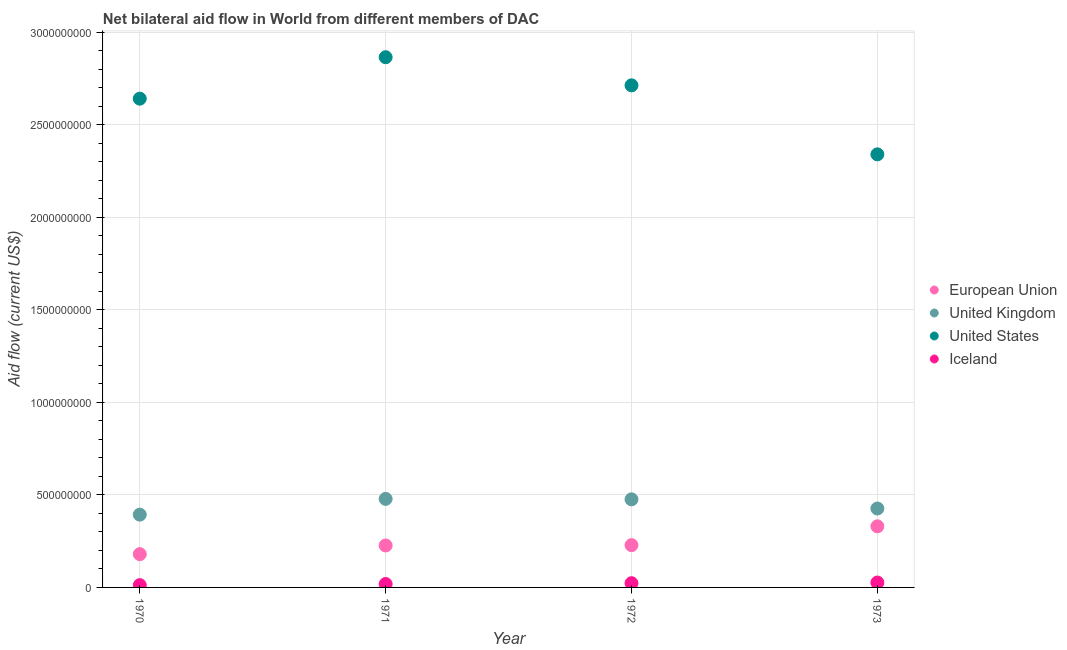How many different coloured dotlines are there?
Offer a very short reply. 4. What is the amount of aid given by us in 1972?
Your answer should be compact. 2.71e+09. Across all years, what is the maximum amount of aid given by eu?
Keep it short and to the point. 3.30e+08. Across all years, what is the minimum amount of aid given by uk?
Offer a very short reply. 3.94e+08. In which year was the amount of aid given by uk maximum?
Offer a terse response. 1971. What is the total amount of aid given by uk in the graph?
Provide a succinct answer. 1.77e+09. What is the difference between the amount of aid given by eu in 1970 and that in 1971?
Offer a terse response. -4.69e+07. What is the difference between the amount of aid given by us in 1972 and the amount of aid given by iceland in 1970?
Provide a succinct answer. 2.70e+09. What is the average amount of aid given by eu per year?
Make the answer very short. 2.41e+08. In the year 1972, what is the difference between the amount of aid given by us and amount of aid given by iceland?
Your answer should be compact. 2.69e+09. In how many years, is the amount of aid given by iceland greater than 1700000000 US$?
Provide a succinct answer. 0. What is the ratio of the amount of aid given by eu in 1971 to that in 1972?
Provide a short and direct response. 0.99. Is the amount of aid given by eu in 1970 less than that in 1973?
Give a very brief answer. Yes. What is the difference between the highest and the second highest amount of aid given by iceland?
Offer a terse response. 3.48e+06. What is the difference between the highest and the lowest amount of aid given by us?
Make the answer very short. 5.25e+08. In how many years, is the amount of aid given by iceland greater than the average amount of aid given by iceland taken over all years?
Provide a succinct answer. 2. Is it the case that in every year, the sum of the amount of aid given by iceland and amount of aid given by us is greater than the sum of amount of aid given by eu and amount of aid given by uk?
Provide a succinct answer. No. Is it the case that in every year, the sum of the amount of aid given by eu and amount of aid given by uk is greater than the amount of aid given by us?
Keep it short and to the point. No. Does the amount of aid given by iceland monotonically increase over the years?
Make the answer very short. Yes. Is the amount of aid given by iceland strictly less than the amount of aid given by uk over the years?
Offer a terse response. Yes. What is the difference between two consecutive major ticks on the Y-axis?
Ensure brevity in your answer.  5.00e+08. Does the graph contain grids?
Your response must be concise. Yes. What is the title of the graph?
Provide a short and direct response. Net bilateral aid flow in World from different members of DAC. Does "Third 20% of population" appear as one of the legend labels in the graph?
Your answer should be compact. No. What is the label or title of the Y-axis?
Make the answer very short. Aid flow (current US$). What is the Aid flow (current US$) in European Union in 1970?
Provide a succinct answer. 1.80e+08. What is the Aid flow (current US$) in United Kingdom in 1970?
Your response must be concise. 3.94e+08. What is the Aid flow (current US$) in United States in 1970?
Provide a short and direct response. 2.64e+09. What is the Aid flow (current US$) in Iceland in 1970?
Offer a terse response. 1.24e+07. What is the Aid flow (current US$) of European Union in 1971?
Ensure brevity in your answer.  2.27e+08. What is the Aid flow (current US$) of United Kingdom in 1971?
Keep it short and to the point. 4.79e+08. What is the Aid flow (current US$) in United States in 1971?
Your answer should be very brief. 2.87e+09. What is the Aid flow (current US$) of Iceland in 1971?
Ensure brevity in your answer.  1.85e+07. What is the Aid flow (current US$) of European Union in 1972?
Make the answer very short. 2.29e+08. What is the Aid flow (current US$) of United Kingdom in 1972?
Make the answer very short. 4.76e+08. What is the Aid flow (current US$) of United States in 1972?
Provide a short and direct response. 2.71e+09. What is the Aid flow (current US$) of Iceland in 1972?
Ensure brevity in your answer.  2.30e+07. What is the Aid flow (current US$) in European Union in 1973?
Ensure brevity in your answer.  3.30e+08. What is the Aid flow (current US$) of United Kingdom in 1973?
Your answer should be very brief. 4.26e+08. What is the Aid flow (current US$) of United States in 1973?
Offer a terse response. 2.34e+09. What is the Aid flow (current US$) of Iceland in 1973?
Your answer should be compact. 2.65e+07. Across all years, what is the maximum Aid flow (current US$) in European Union?
Give a very brief answer. 3.30e+08. Across all years, what is the maximum Aid flow (current US$) in United Kingdom?
Your response must be concise. 4.79e+08. Across all years, what is the maximum Aid flow (current US$) in United States?
Offer a very short reply. 2.87e+09. Across all years, what is the maximum Aid flow (current US$) in Iceland?
Your response must be concise. 2.65e+07. Across all years, what is the minimum Aid flow (current US$) in European Union?
Make the answer very short. 1.80e+08. Across all years, what is the minimum Aid flow (current US$) in United Kingdom?
Your response must be concise. 3.94e+08. Across all years, what is the minimum Aid flow (current US$) of United States?
Keep it short and to the point. 2.34e+09. Across all years, what is the minimum Aid flow (current US$) of Iceland?
Ensure brevity in your answer.  1.24e+07. What is the total Aid flow (current US$) in European Union in the graph?
Offer a very short reply. 9.65e+08. What is the total Aid flow (current US$) in United Kingdom in the graph?
Offer a terse response. 1.77e+09. What is the total Aid flow (current US$) of United States in the graph?
Give a very brief answer. 1.06e+1. What is the total Aid flow (current US$) in Iceland in the graph?
Give a very brief answer. 8.04e+07. What is the difference between the Aid flow (current US$) in European Union in 1970 and that in 1971?
Ensure brevity in your answer.  -4.69e+07. What is the difference between the Aid flow (current US$) in United Kingdom in 1970 and that in 1971?
Your answer should be very brief. -8.51e+07. What is the difference between the Aid flow (current US$) in United States in 1970 and that in 1971?
Ensure brevity in your answer.  -2.24e+08. What is the difference between the Aid flow (current US$) of Iceland in 1970 and that in 1971?
Ensure brevity in your answer.  -6.11e+06. What is the difference between the Aid flow (current US$) of European Union in 1970 and that in 1972?
Ensure brevity in your answer.  -4.86e+07. What is the difference between the Aid flow (current US$) of United Kingdom in 1970 and that in 1972?
Offer a very short reply. -8.26e+07. What is the difference between the Aid flow (current US$) of United States in 1970 and that in 1972?
Your answer should be very brief. -7.20e+07. What is the difference between the Aid flow (current US$) in Iceland in 1970 and that in 1972?
Provide a succinct answer. -1.06e+07. What is the difference between the Aid flow (current US$) of European Union in 1970 and that in 1973?
Make the answer very short. -1.50e+08. What is the difference between the Aid flow (current US$) in United Kingdom in 1970 and that in 1973?
Keep it short and to the point. -3.30e+07. What is the difference between the Aid flow (current US$) in United States in 1970 and that in 1973?
Provide a succinct answer. 3.01e+08. What is the difference between the Aid flow (current US$) in Iceland in 1970 and that in 1973?
Your answer should be compact. -1.41e+07. What is the difference between the Aid flow (current US$) of European Union in 1971 and that in 1972?
Make the answer very short. -1.74e+06. What is the difference between the Aid flow (current US$) in United Kingdom in 1971 and that in 1972?
Provide a succinct answer. 2.50e+06. What is the difference between the Aid flow (current US$) in United States in 1971 and that in 1972?
Provide a succinct answer. 1.52e+08. What is the difference between the Aid flow (current US$) in Iceland in 1971 and that in 1972?
Your response must be concise. -4.51e+06. What is the difference between the Aid flow (current US$) in European Union in 1971 and that in 1973?
Offer a very short reply. -1.04e+08. What is the difference between the Aid flow (current US$) in United Kingdom in 1971 and that in 1973?
Give a very brief answer. 5.22e+07. What is the difference between the Aid flow (current US$) of United States in 1971 and that in 1973?
Give a very brief answer. 5.25e+08. What is the difference between the Aid flow (current US$) in Iceland in 1971 and that in 1973?
Provide a succinct answer. -7.99e+06. What is the difference between the Aid flow (current US$) in European Union in 1972 and that in 1973?
Offer a very short reply. -1.02e+08. What is the difference between the Aid flow (current US$) in United Kingdom in 1972 and that in 1973?
Offer a terse response. 4.97e+07. What is the difference between the Aid flow (current US$) in United States in 1972 and that in 1973?
Ensure brevity in your answer.  3.73e+08. What is the difference between the Aid flow (current US$) in Iceland in 1972 and that in 1973?
Your response must be concise. -3.48e+06. What is the difference between the Aid flow (current US$) of European Union in 1970 and the Aid flow (current US$) of United Kingdom in 1971?
Your answer should be very brief. -2.99e+08. What is the difference between the Aid flow (current US$) of European Union in 1970 and the Aid flow (current US$) of United States in 1971?
Your answer should be compact. -2.69e+09. What is the difference between the Aid flow (current US$) of European Union in 1970 and the Aid flow (current US$) of Iceland in 1971?
Give a very brief answer. 1.61e+08. What is the difference between the Aid flow (current US$) of United Kingdom in 1970 and the Aid flow (current US$) of United States in 1971?
Make the answer very short. -2.47e+09. What is the difference between the Aid flow (current US$) of United Kingdom in 1970 and the Aid flow (current US$) of Iceland in 1971?
Your response must be concise. 3.75e+08. What is the difference between the Aid flow (current US$) of United States in 1970 and the Aid flow (current US$) of Iceland in 1971?
Provide a succinct answer. 2.62e+09. What is the difference between the Aid flow (current US$) in European Union in 1970 and the Aid flow (current US$) in United Kingdom in 1972?
Keep it short and to the point. -2.96e+08. What is the difference between the Aid flow (current US$) of European Union in 1970 and the Aid flow (current US$) of United States in 1972?
Offer a very short reply. -2.53e+09. What is the difference between the Aid flow (current US$) in European Union in 1970 and the Aid flow (current US$) in Iceland in 1972?
Give a very brief answer. 1.57e+08. What is the difference between the Aid flow (current US$) in United Kingdom in 1970 and the Aid flow (current US$) in United States in 1972?
Your response must be concise. -2.32e+09. What is the difference between the Aid flow (current US$) of United Kingdom in 1970 and the Aid flow (current US$) of Iceland in 1972?
Your answer should be very brief. 3.70e+08. What is the difference between the Aid flow (current US$) of United States in 1970 and the Aid flow (current US$) of Iceland in 1972?
Offer a very short reply. 2.62e+09. What is the difference between the Aid flow (current US$) in European Union in 1970 and the Aid flow (current US$) in United Kingdom in 1973?
Provide a short and direct response. -2.47e+08. What is the difference between the Aid flow (current US$) of European Union in 1970 and the Aid flow (current US$) of United States in 1973?
Keep it short and to the point. -2.16e+09. What is the difference between the Aid flow (current US$) of European Union in 1970 and the Aid flow (current US$) of Iceland in 1973?
Your response must be concise. 1.53e+08. What is the difference between the Aid flow (current US$) in United Kingdom in 1970 and the Aid flow (current US$) in United States in 1973?
Keep it short and to the point. -1.95e+09. What is the difference between the Aid flow (current US$) in United Kingdom in 1970 and the Aid flow (current US$) in Iceland in 1973?
Give a very brief answer. 3.67e+08. What is the difference between the Aid flow (current US$) of United States in 1970 and the Aid flow (current US$) of Iceland in 1973?
Your answer should be very brief. 2.62e+09. What is the difference between the Aid flow (current US$) in European Union in 1971 and the Aid flow (current US$) in United Kingdom in 1972?
Your response must be concise. -2.49e+08. What is the difference between the Aid flow (current US$) in European Union in 1971 and the Aid flow (current US$) in United States in 1972?
Offer a very short reply. -2.49e+09. What is the difference between the Aid flow (current US$) in European Union in 1971 and the Aid flow (current US$) in Iceland in 1972?
Ensure brevity in your answer.  2.04e+08. What is the difference between the Aid flow (current US$) of United Kingdom in 1971 and the Aid flow (current US$) of United States in 1972?
Your answer should be compact. -2.24e+09. What is the difference between the Aid flow (current US$) in United Kingdom in 1971 and the Aid flow (current US$) in Iceland in 1972?
Provide a succinct answer. 4.56e+08. What is the difference between the Aid flow (current US$) of United States in 1971 and the Aid flow (current US$) of Iceland in 1972?
Ensure brevity in your answer.  2.84e+09. What is the difference between the Aid flow (current US$) in European Union in 1971 and the Aid flow (current US$) in United Kingdom in 1973?
Provide a succinct answer. -2.00e+08. What is the difference between the Aid flow (current US$) of European Union in 1971 and the Aid flow (current US$) of United States in 1973?
Provide a short and direct response. -2.11e+09. What is the difference between the Aid flow (current US$) in European Union in 1971 and the Aid flow (current US$) in Iceland in 1973?
Offer a very short reply. 2.00e+08. What is the difference between the Aid flow (current US$) in United Kingdom in 1971 and the Aid flow (current US$) in United States in 1973?
Your answer should be very brief. -1.86e+09. What is the difference between the Aid flow (current US$) in United Kingdom in 1971 and the Aid flow (current US$) in Iceland in 1973?
Your answer should be compact. 4.52e+08. What is the difference between the Aid flow (current US$) in United States in 1971 and the Aid flow (current US$) in Iceland in 1973?
Ensure brevity in your answer.  2.84e+09. What is the difference between the Aid flow (current US$) in European Union in 1972 and the Aid flow (current US$) in United Kingdom in 1973?
Provide a short and direct response. -1.98e+08. What is the difference between the Aid flow (current US$) in European Union in 1972 and the Aid flow (current US$) in United States in 1973?
Your answer should be very brief. -2.11e+09. What is the difference between the Aid flow (current US$) of European Union in 1972 and the Aid flow (current US$) of Iceland in 1973?
Give a very brief answer. 2.02e+08. What is the difference between the Aid flow (current US$) in United Kingdom in 1972 and the Aid flow (current US$) in United States in 1973?
Offer a very short reply. -1.86e+09. What is the difference between the Aid flow (current US$) of United Kingdom in 1972 and the Aid flow (current US$) of Iceland in 1973?
Offer a terse response. 4.50e+08. What is the difference between the Aid flow (current US$) in United States in 1972 and the Aid flow (current US$) in Iceland in 1973?
Keep it short and to the point. 2.69e+09. What is the average Aid flow (current US$) in European Union per year?
Give a very brief answer. 2.41e+08. What is the average Aid flow (current US$) of United Kingdom per year?
Your response must be concise. 4.44e+08. What is the average Aid flow (current US$) in United States per year?
Ensure brevity in your answer.  2.64e+09. What is the average Aid flow (current US$) of Iceland per year?
Your answer should be compact. 2.01e+07. In the year 1970, what is the difference between the Aid flow (current US$) in European Union and Aid flow (current US$) in United Kingdom?
Provide a succinct answer. -2.14e+08. In the year 1970, what is the difference between the Aid flow (current US$) of European Union and Aid flow (current US$) of United States?
Provide a short and direct response. -2.46e+09. In the year 1970, what is the difference between the Aid flow (current US$) of European Union and Aid flow (current US$) of Iceland?
Ensure brevity in your answer.  1.67e+08. In the year 1970, what is the difference between the Aid flow (current US$) of United Kingdom and Aid flow (current US$) of United States?
Keep it short and to the point. -2.25e+09. In the year 1970, what is the difference between the Aid flow (current US$) of United Kingdom and Aid flow (current US$) of Iceland?
Keep it short and to the point. 3.81e+08. In the year 1970, what is the difference between the Aid flow (current US$) of United States and Aid flow (current US$) of Iceland?
Keep it short and to the point. 2.63e+09. In the year 1971, what is the difference between the Aid flow (current US$) of European Union and Aid flow (current US$) of United Kingdom?
Make the answer very short. -2.52e+08. In the year 1971, what is the difference between the Aid flow (current US$) of European Union and Aid flow (current US$) of United States?
Your response must be concise. -2.64e+09. In the year 1971, what is the difference between the Aid flow (current US$) of European Union and Aid flow (current US$) of Iceland?
Your answer should be compact. 2.08e+08. In the year 1971, what is the difference between the Aid flow (current US$) in United Kingdom and Aid flow (current US$) in United States?
Your response must be concise. -2.39e+09. In the year 1971, what is the difference between the Aid flow (current US$) in United Kingdom and Aid flow (current US$) in Iceland?
Offer a very short reply. 4.60e+08. In the year 1971, what is the difference between the Aid flow (current US$) in United States and Aid flow (current US$) in Iceland?
Provide a succinct answer. 2.85e+09. In the year 1972, what is the difference between the Aid flow (current US$) in European Union and Aid flow (current US$) in United Kingdom?
Offer a very short reply. -2.48e+08. In the year 1972, what is the difference between the Aid flow (current US$) in European Union and Aid flow (current US$) in United States?
Ensure brevity in your answer.  -2.49e+09. In the year 1972, what is the difference between the Aid flow (current US$) of European Union and Aid flow (current US$) of Iceland?
Offer a very short reply. 2.06e+08. In the year 1972, what is the difference between the Aid flow (current US$) in United Kingdom and Aid flow (current US$) in United States?
Provide a succinct answer. -2.24e+09. In the year 1972, what is the difference between the Aid flow (current US$) of United Kingdom and Aid flow (current US$) of Iceland?
Offer a very short reply. 4.53e+08. In the year 1972, what is the difference between the Aid flow (current US$) of United States and Aid flow (current US$) of Iceland?
Ensure brevity in your answer.  2.69e+09. In the year 1973, what is the difference between the Aid flow (current US$) in European Union and Aid flow (current US$) in United Kingdom?
Keep it short and to the point. -9.62e+07. In the year 1973, what is the difference between the Aid flow (current US$) of European Union and Aid flow (current US$) of United States?
Your answer should be very brief. -2.01e+09. In the year 1973, what is the difference between the Aid flow (current US$) of European Union and Aid flow (current US$) of Iceland?
Offer a very short reply. 3.04e+08. In the year 1973, what is the difference between the Aid flow (current US$) in United Kingdom and Aid flow (current US$) in United States?
Make the answer very short. -1.91e+09. In the year 1973, what is the difference between the Aid flow (current US$) in United Kingdom and Aid flow (current US$) in Iceland?
Make the answer very short. 4.00e+08. In the year 1973, what is the difference between the Aid flow (current US$) of United States and Aid flow (current US$) of Iceland?
Keep it short and to the point. 2.31e+09. What is the ratio of the Aid flow (current US$) in European Union in 1970 to that in 1971?
Provide a succinct answer. 0.79. What is the ratio of the Aid flow (current US$) in United Kingdom in 1970 to that in 1971?
Keep it short and to the point. 0.82. What is the ratio of the Aid flow (current US$) in United States in 1970 to that in 1971?
Keep it short and to the point. 0.92. What is the ratio of the Aid flow (current US$) of Iceland in 1970 to that in 1971?
Your response must be concise. 0.67. What is the ratio of the Aid flow (current US$) in European Union in 1970 to that in 1972?
Your answer should be very brief. 0.79. What is the ratio of the Aid flow (current US$) of United Kingdom in 1970 to that in 1972?
Offer a terse response. 0.83. What is the ratio of the Aid flow (current US$) in United States in 1970 to that in 1972?
Give a very brief answer. 0.97. What is the ratio of the Aid flow (current US$) of Iceland in 1970 to that in 1972?
Offer a terse response. 0.54. What is the ratio of the Aid flow (current US$) in European Union in 1970 to that in 1973?
Offer a terse response. 0.54. What is the ratio of the Aid flow (current US$) of United Kingdom in 1970 to that in 1973?
Give a very brief answer. 0.92. What is the ratio of the Aid flow (current US$) in United States in 1970 to that in 1973?
Provide a succinct answer. 1.13. What is the ratio of the Aid flow (current US$) in Iceland in 1970 to that in 1973?
Your answer should be compact. 0.47. What is the ratio of the Aid flow (current US$) of European Union in 1971 to that in 1972?
Ensure brevity in your answer.  0.99. What is the ratio of the Aid flow (current US$) in United Kingdom in 1971 to that in 1972?
Provide a short and direct response. 1.01. What is the ratio of the Aid flow (current US$) in United States in 1971 to that in 1972?
Offer a very short reply. 1.06. What is the ratio of the Aid flow (current US$) of Iceland in 1971 to that in 1972?
Offer a terse response. 0.8. What is the ratio of the Aid flow (current US$) of European Union in 1971 to that in 1973?
Your answer should be very brief. 0.69. What is the ratio of the Aid flow (current US$) in United Kingdom in 1971 to that in 1973?
Give a very brief answer. 1.12. What is the ratio of the Aid flow (current US$) in United States in 1971 to that in 1973?
Make the answer very short. 1.22. What is the ratio of the Aid flow (current US$) in Iceland in 1971 to that in 1973?
Offer a very short reply. 0.7. What is the ratio of the Aid flow (current US$) of European Union in 1972 to that in 1973?
Make the answer very short. 0.69. What is the ratio of the Aid flow (current US$) in United Kingdom in 1972 to that in 1973?
Give a very brief answer. 1.12. What is the ratio of the Aid flow (current US$) of United States in 1972 to that in 1973?
Keep it short and to the point. 1.16. What is the ratio of the Aid flow (current US$) in Iceland in 1972 to that in 1973?
Provide a short and direct response. 0.87. What is the difference between the highest and the second highest Aid flow (current US$) of European Union?
Make the answer very short. 1.02e+08. What is the difference between the highest and the second highest Aid flow (current US$) in United Kingdom?
Ensure brevity in your answer.  2.50e+06. What is the difference between the highest and the second highest Aid flow (current US$) of United States?
Your answer should be very brief. 1.52e+08. What is the difference between the highest and the second highest Aid flow (current US$) in Iceland?
Keep it short and to the point. 3.48e+06. What is the difference between the highest and the lowest Aid flow (current US$) in European Union?
Your response must be concise. 1.50e+08. What is the difference between the highest and the lowest Aid flow (current US$) in United Kingdom?
Ensure brevity in your answer.  8.51e+07. What is the difference between the highest and the lowest Aid flow (current US$) in United States?
Your response must be concise. 5.25e+08. What is the difference between the highest and the lowest Aid flow (current US$) in Iceland?
Provide a succinct answer. 1.41e+07. 